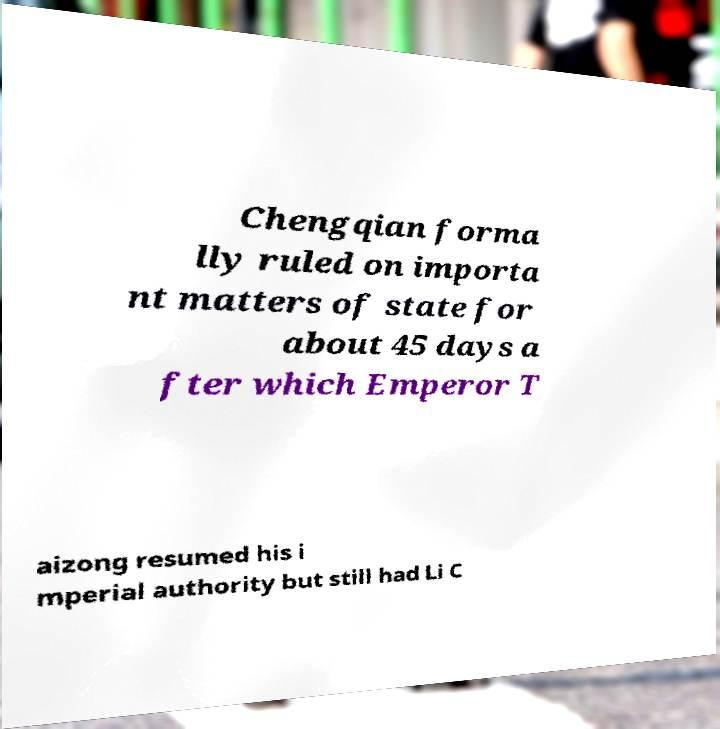Please identify and transcribe the text found in this image. Chengqian forma lly ruled on importa nt matters of state for about 45 days a fter which Emperor T aizong resumed his i mperial authority but still had Li C 